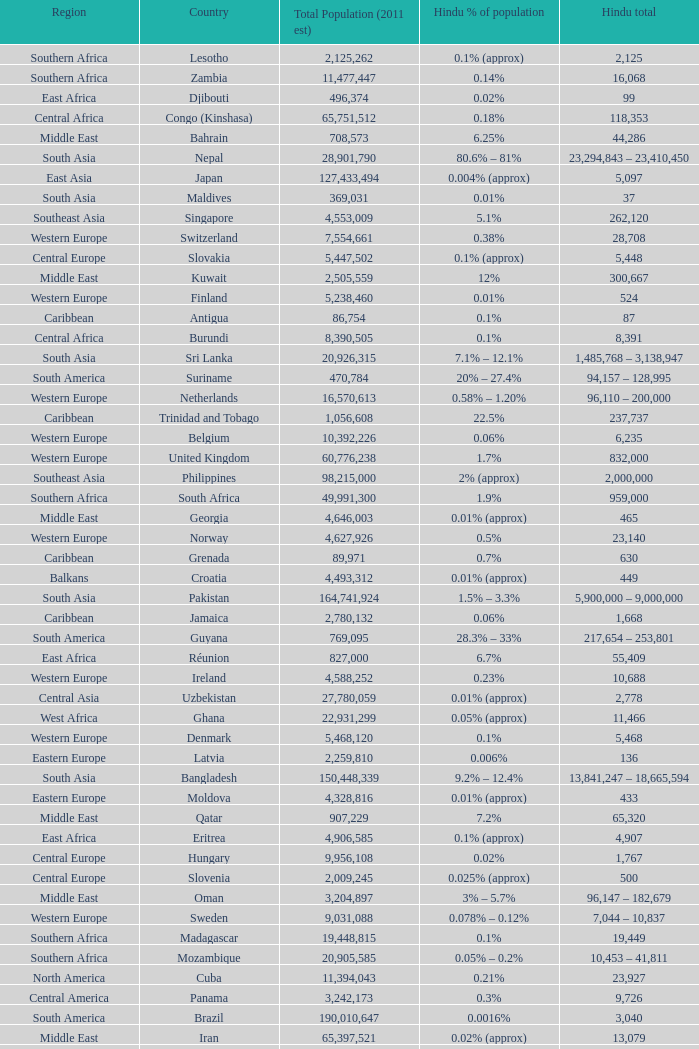Total Population (2011 est) larger than 30,262,610, and a Hindu total of 63,718 involves what country? France. 